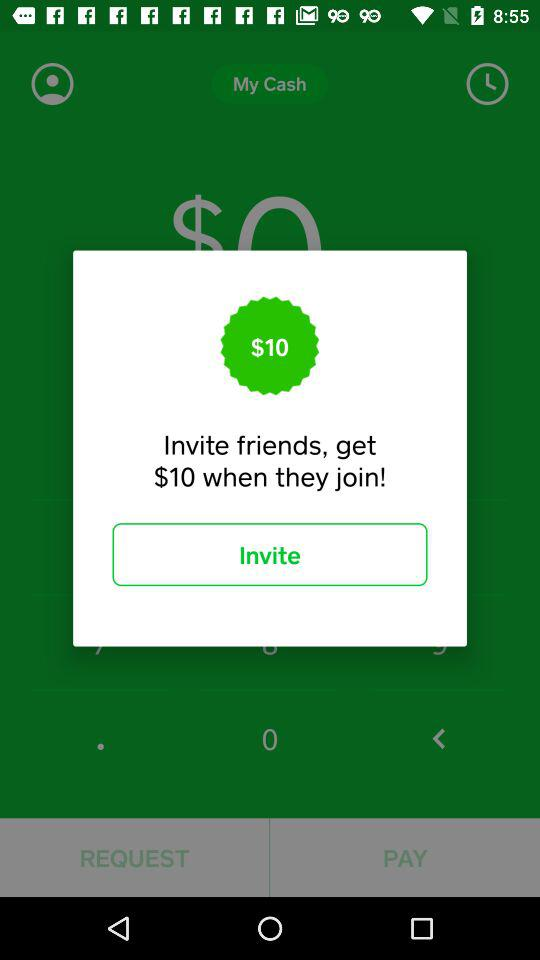How much cash does the user have in total?
When the provided information is insufficient, respond with <no answer>. <no answer> 